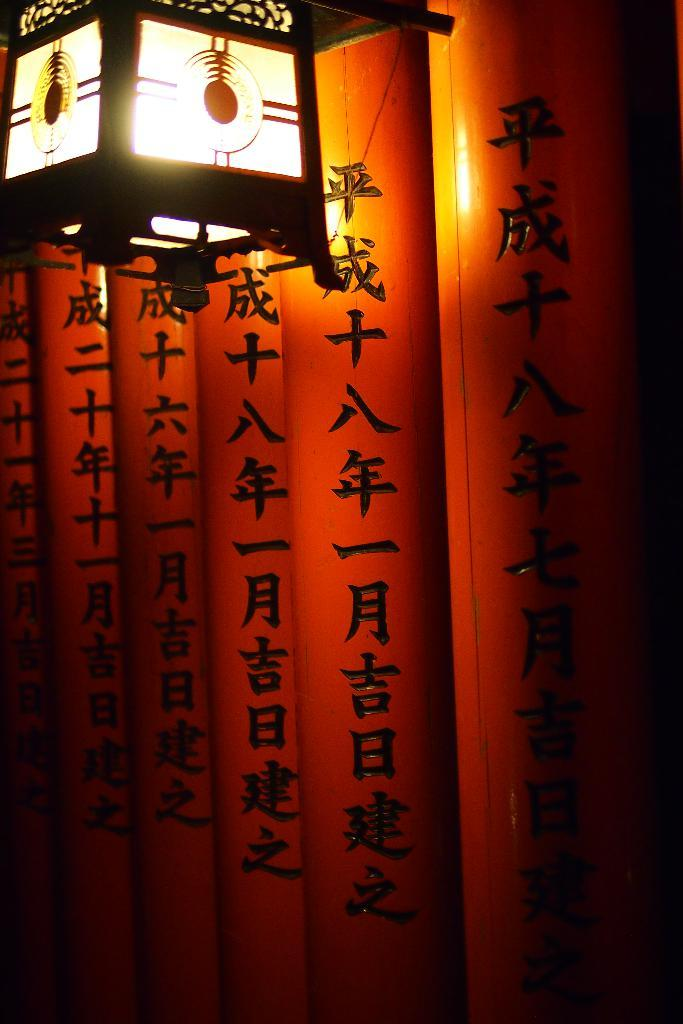What type of signage is present in the image? There are hoardings in the image. Can you describe any other elements in the image? There is a light visible in the image. How many spiders are crawling on the hoardings in the image? There are no spiders present in the image. What type of destruction can be seen on the hoardings in the image? There is no destruction visible on the hoardings in the image. 